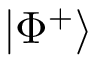Convert formula to latex. <formula><loc_0><loc_0><loc_500><loc_500>| \Phi ^ { + } \rangle</formula> 